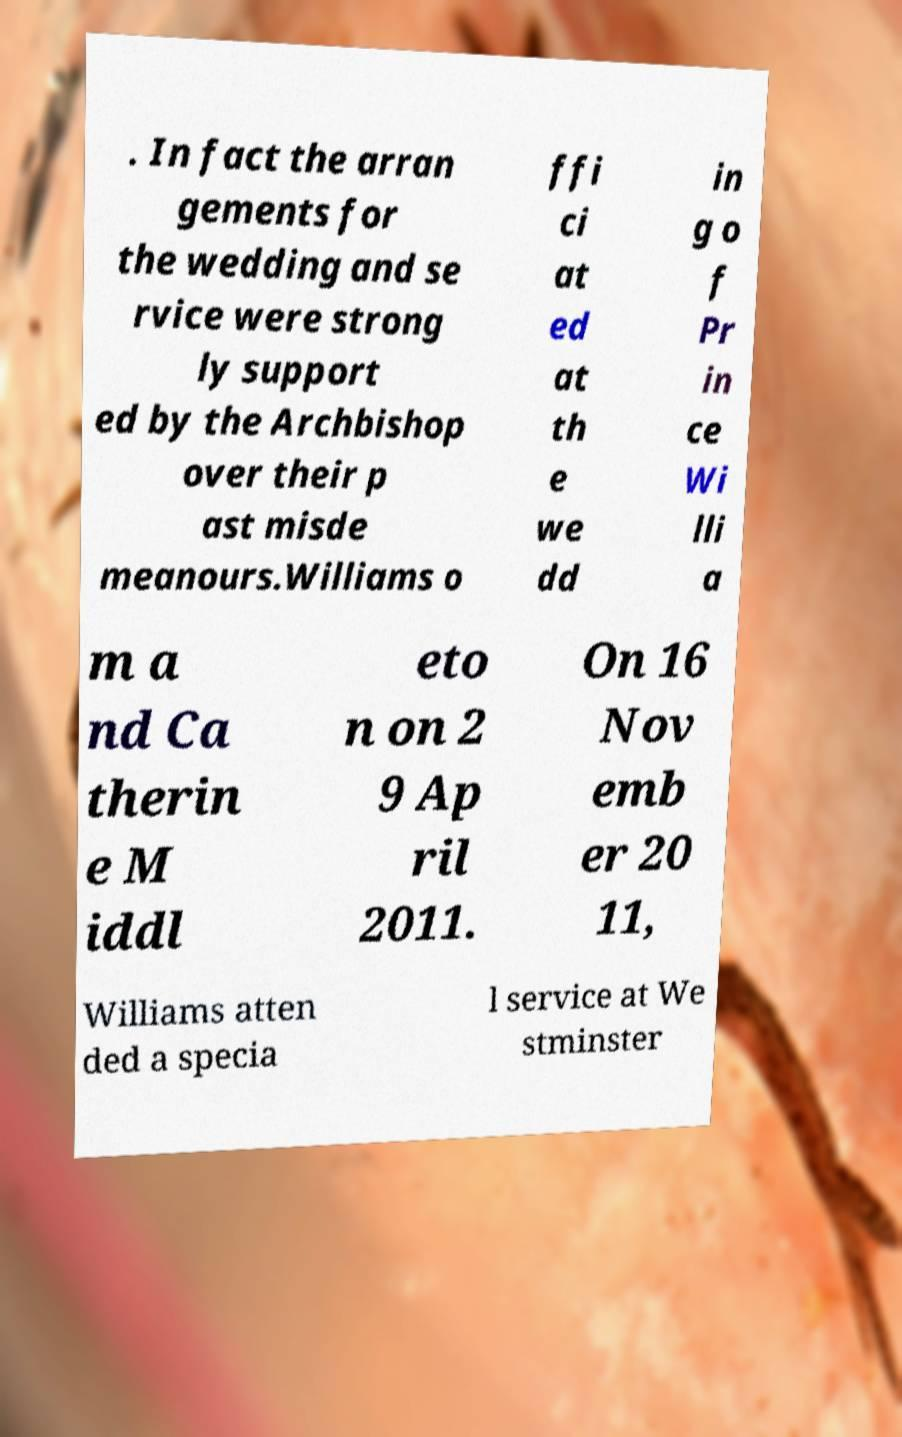Could you assist in decoding the text presented in this image and type it out clearly? . In fact the arran gements for the wedding and se rvice were strong ly support ed by the Archbishop over their p ast misde meanours.Williams o ffi ci at ed at th e we dd in g o f Pr in ce Wi lli a m a nd Ca therin e M iddl eto n on 2 9 Ap ril 2011. On 16 Nov emb er 20 11, Williams atten ded a specia l service at We stminster 